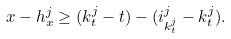<formula> <loc_0><loc_0><loc_500><loc_500>x - h ^ { j } _ { x } \geq ( k ^ { j } _ { t } - t ) - ( i ^ { j } _ { k ^ { j } _ { t } } - { k ^ { j } _ { t } } ) .</formula> 